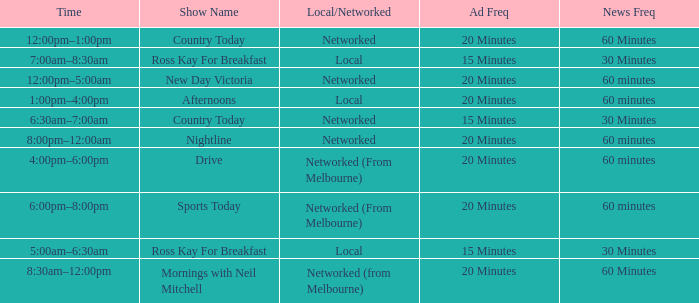What News Freq has a Time of 1:00pm–4:00pm? 60 minutes. 